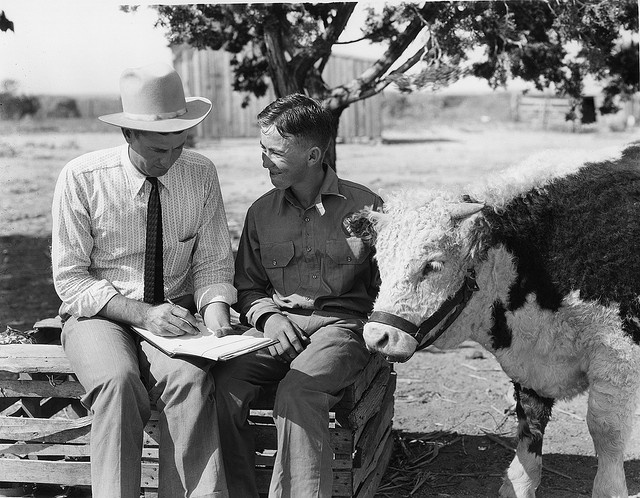Describe the objects in this image and their specific colors. I can see cow in white, black, gray, lightgray, and darkgray tones, people in white, darkgray, lightgray, gray, and black tones, people in white, black, gray, darkgray, and lightgray tones, bench in white, darkgray, lightgray, black, and gray tones, and tie in white, black, gray, darkgray, and lightgray tones in this image. 